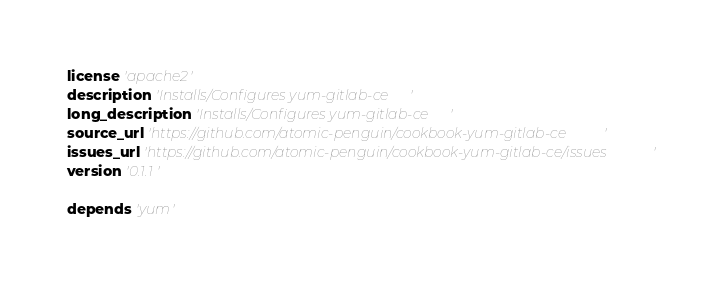<code> <loc_0><loc_0><loc_500><loc_500><_Ruby_>license 'apache2'
description 'Installs/Configures yum-gitlab-ce'
long_description 'Installs/Configures yum-gitlab-ce'
source_url 'https://github.com/atomic-penguin/cookbook-yum-gitlab-ce'
issues_url 'https://github.com/atomic-penguin/cookbook-yum-gitlab-ce/issues'
version '0.1.1'

depends 'yum'
</code> 